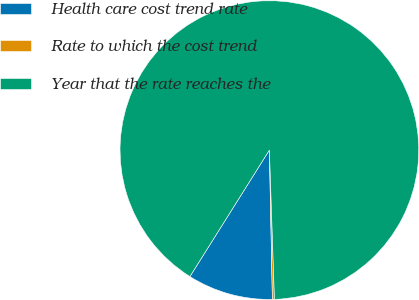Convert chart to OTSL. <chart><loc_0><loc_0><loc_500><loc_500><pie_chart><fcel>Health care cost trend rate<fcel>Rate to which the cost trend<fcel>Year that the rate reaches the<nl><fcel>9.25%<fcel>0.22%<fcel>90.52%<nl></chart> 